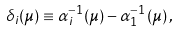Convert formula to latex. <formula><loc_0><loc_0><loc_500><loc_500>\delta _ { i } ( \mu ) \equiv \alpha ^ { - 1 } _ { i } ( \mu ) - \alpha ^ { - 1 } _ { 1 } ( \mu ) \, ,</formula> 